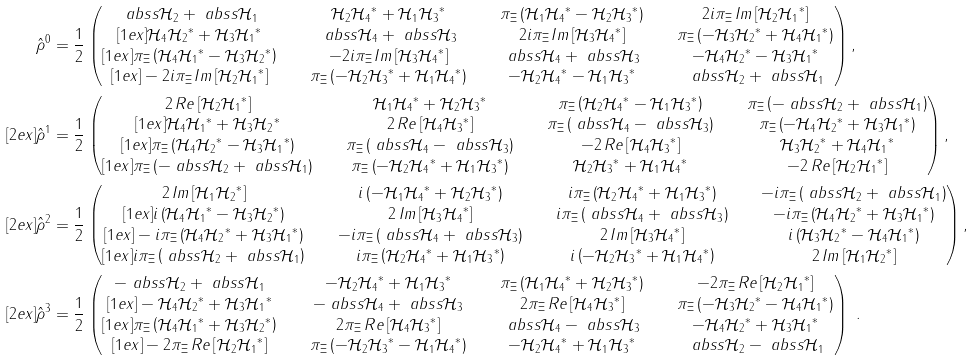<formula> <loc_0><loc_0><loc_500><loc_500>\hat { \rho } ^ { 0 } & = \frac { 1 } { 2 } \begin{pmatrix} \ a b s s { \mathcal { H } _ { 2 } } + \ a b s s { \mathcal { H } _ { 1 } } \quad & \mathcal { H } _ { 2 } { \mathcal { H } _ { 4 } } ^ { * } + \mathcal { H } _ { 1 } { \mathcal { H } _ { 3 } } ^ { * } \quad & \pi _ { \Xi } \left ( \mathcal { H } _ { 1 } { \mathcal { H } _ { 4 } } ^ { * } - \mathcal { H } _ { 2 } { \mathcal { H } _ { 3 } } ^ { * } \right ) \quad & 2 i \pi _ { \Xi } \, I m \left [ \mathcal { H } _ { 2 } { \mathcal { H } _ { 1 } } ^ { * } \right ] \\ [ 1 e x ] \mathcal { H } _ { 4 } { \mathcal { H } _ { 2 } } ^ { * } + \mathcal { H } _ { 3 } { \mathcal { H } _ { 1 } } ^ { * } \quad & \ a b s s { \mathcal { H } _ { 4 } } + \ a b s s { \mathcal { H } _ { 3 } } \quad & 2 i \pi _ { \Xi } \, I m \left [ \mathcal { H } _ { 3 } { \mathcal { H } _ { 4 } } ^ { * } \right ] \quad & \pi _ { \Xi } \left ( - \mathcal { H } _ { 3 } { \mathcal { H } _ { 2 } } ^ { * } + \mathcal { H } _ { 4 } { \mathcal { H } _ { 1 } } ^ { * } \right ) \\ [ 1 e x ] \pi _ { \Xi } \left ( \mathcal { H } _ { 4 } { \mathcal { H } _ { 1 } } ^ { * } - \mathcal { H } _ { 3 } { \mathcal { H } _ { 2 } } ^ { * } \right ) \quad & - 2 i \pi _ { \Xi } \, I m \left [ \mathcal { H } _ { 3 } { \mathcal { H } _ { 4 } } ^ { * } \right ] \quad & \ a b s s { \mathcal { H } _ { 4 } } + \ a b s s { \mathcal { H } _ { 3 } } \quad & - \mathcal { H } _ { 4 } { \mathcal { H } _ { 2 } } ^ { * } - \mathcal { H } _ { 3 } { \mathcal { H } _ { 1 } } ^ { * } \\ [ 1 e x ] - 2 i \pi _ { \Xi } \, I m \left [ \mathcal { H } _ { 2 } { \mathcal { H } _ { 1 } } ^ { * } \right ] \quad & \pi _ { \Xi } \left ( - \mathcal { H } _ { 2 } { \mathcal { H } _ { 3 } } ^ { * } + \mathcal { H } _ { 1 } { \mathcal { H } _ { 4 } } ^ { * } \right ) \quad & - \mathcal { H } _ { 2 } { \mathcal { H } _ { 4 } } ^ { * } - \mathcal { H } _ { 1 } { \mathcal { H } _ { 3 } } ^ { * } \quad & \ a b s s { \mathcal { H } _ { 2 } } + \ a b s s { \mathcal { H } _ { 1 } } \end{pmatrix} , \\ [ 2 e x ] \hat { \rho } ^ { 1 } & = \frac { 1 } { 2 } \begin{pmatrix} 2 \, R e \left [ \mathcal { H } _ { 2 } { \mathcal { H } _ { 1 } } ^ { * } \right ] \quad & \mathcal { H } _ { 1 } { \mathcal { H } _ { 4 } } ^ { * } + \mathcal { H } _ { 2 } { \mathcal { H } _ { 3 } } ^ { * } \quad & \pi _ { \Xi } \left ( \mathcal { H } _ { 2 } { \mathcal { H } _ { 4 } } ^ { * } - \mathcal { H } _ { 1 } { \mathcal { H } _ { 3 } } ^ { * } \right ) \quad & \pi _ { \Xi } \left ( - \ a b s s { \mathcal { H } _ { 2 } } + \ a b s s { \mathcal { H } _ { 1 } } \right ) \\ [ 1 e x ] \mathcal { H } _ { 4 } { \mathcal { H } _ { 1 } } ^ { * } + \mathcal { H } _ { 3 } { \mathcal { H } _ { 2 } } ^ { * } \quad & 2 \, R e \left [ \mathcal { H } _ { 4 } { \mathcal { H } _ { 3 } } ^ { * } \right ] \quad & \pi _ { \Xi } \left ( \ a b s s { \mathcal { H } _ { 4 } } - \ a b s s { \mathcal { H } _ { 3 } } \right ) \quad & \pi _ { \Xi } \left ( - \mathcal { H } _ { 4 } { \mathcal { H } _ { 2 } } ^ { * } + \mathcal { H } _ { 3 } { \mathcal { H } _ { 1 } } ^ { * } \right ) \\ [ 1 e x ] \pi _ { \Xi } \left ( \mathcal { H } _ { 4 } { \mathcal { H } _ { 2 } } ^ { * } - \mathcal { H } _ { 3 } { \mathcal { H } _ { 1 } } ^ { * } \right ) \quad & \pi _ { \Xi } \left ( \ a b s s { \mathcal { H } _ { 4 } } - \ a b s s { \mathcal { H } _ { 3 } } \right ) \quad & - 2 \, R e \left [ \mathcal { H } _ { 4 } { \mathcal { H } _ { 3 } } ^ { * } \right ] \quad & \mathcal { H } _ { 3 } { \mathcal { H } _ { 2 } } ^ { * } + \mathcal { H } _ { 4 } { \mathcal { H } _ { 1 } } ^ { * } \\ [ 1 e x ] \pi _ { \Xi } \left ( - \ a b s s { \mathcal { H } _ { 2 } } + \ a b s s { \mathcal { H } _ { 1 } } \right ) \quad & \pi _ { \Xi } \left ( - \mathcal { H } _ { 2 } { \mathcal { H } _ { 4 } } ^ { * } + \mathcal { H } _ { 1 } { \mathcal { H } _ { 3 } } ^ { * } \right ) \quad & \mathcal { H } _ { 2 } { \mathcal { H } _ { 3 } } ^ { * } + \mathcal { H } _ { 1 } { \mathcal { H } _ { 4 } } ^ { * } \quad & - 2 \, R e \left [ \mathcal { H } _ { 2 } { \mathcal { H } _ { 1 } } ^ { * } \right ] \end{pmatrix} , \\ [ 2 e x ] \hat { \rho } ^ { 2 } & = \frac { 1 } { 2 } \begin{pmatrix} 2 \, I m \left [ \mathcal { H } _ { 1 } { \mathcal { H } _ { 2 } } ^ { * } \right ] \quad & i \left ( - \mathcal { H } _ { 1 } { \mathcal { H } _ { 4 } } ^ { * } + \mathcal { H } _ { 2 } { \mathcal { H } _ { 3 } } ^ { * } \right ) \quad & i \pi _ { \Xi } \left ( \mathcal { H } _ { 2 } { \mathcal { H } _ { 4 } } ^ { * } + \mathcal { H } _ { 1 } { \mathcal { H } _ { 3 } } ^ { * } \right ) \quad & - i \pi _ { \Xi } \left ( \ a b s s { \mathcal { H } _ { 2 } } + \ a b s s { \mathcal { H } _ { 1 } } \right ) \\ [ 1 e x ] i \left ( \mathcal { H } _ { 4 } { \mathcal { H } _ { 1 } } ^ { * } - \mathcal { H } _ { 3 } { \mathcal { H } _ { 2 } } ^ { * } \right ) \quad & 2 \, I m \left [ \mathcal { H } _ { 3 } { \mathcal { H } _ { 4 } } ^ { * } \right ] \quad & i \pi _ { \Xi } \left ( \ a b s s { \mathcal { H } _ { 4 } } + \ a b s s { \mathcal { H } _ { 3 } } \right ) \quad & - i \pi _ { \Xi } \left ( \mathcal { H } _ { 4 } { \mathcal { H } _ { 2 } } ^ { * } + \mathcal { H } _ { 3 } { \mathcal { H } _ { 1 } } ^ { * } \right ) \\ [ 1 e x ] - i \pi _ { \Xi } \left ( \mathcal { H } _ { 4 } { \mathcal { H } _ { 2 } } ^ { * } + \mathcal { H } _ { 3 } { \mathcal { H } _ { 1 } } ^ { * } \right ) \quad & - i \pi _ { \Xi } \left ( \ a b s s { \mathcal { H } _ { 4 } } + \ a b s s { \mathcal { H } _ { 3 } } \right ) \quad & 2 \, I m \left [ \mathcal { H } _ { 3 } { \mathcal { H } _ { 4 } } ^ { * } \right ] \quad & i \left ( \mathcal { H } _ { 3 } { \mathcal { H } _ { 2 } } ^ { * } - \mathcal { H } _ { 4 } { \mathcal { H } _ { 1 } } ^ { * } \right ) \\ [ 1 e x ] i \pi _ { \Xi } \left ( \ a b s s { \mathcal { H } _ { 2 } } + \ a b s s { \mathcal { H } _ { 1 } } \right ) \quad & i \pi _ { \Xi } \left ( \mathcal { H } _ { 2 } { \mathcal { H } _ { 4 } } ^ { * } + \mathcal { H } _ { 1 } { \mathcal { H } _ { 3 } } ^ { * } \right ) \quad & i \left ( - \mathcal { H } _ { 2 } { \mathcal { H } _ { 3 } } ^ { * } + \mathcal { H } _ { 1 } { \mathcal { H } _ { 4 } } ^ { * } \right ) \quad & 2 \, I m \left [ \mathcal { H } _ { 1 } { \mathcal { H } _ { 2 } } ^ { * } \right ] \end{pmatrix} , \\ [ 2 e x ] \hat { \rho } ^ { 3 } & = \frac { 1 } { 2 } \begin{pmatrix} - \ a b s s { \mathcal { H } _ { 2 } } + \ a b s s { \mathcal { H } _ { 1 } } \quad & - \mathcal { H } _ { 2 } { \mathcal { H } _ { 4 } } ^ { * } + \mathcal { H } _ { 1 } { \mathcal { H } _ { 3 } } ^ { * } \quad & \pi _ { \Xi } \left ( \mathcal { H } _ { 1 } { \mathcal { H } _ { 4 } } ^ { * } + \mathcal { H } _ { 2 } { \mathcal { H } _ { 3 } } ^ { * } \right ) \quad & - 2 \pi _ { \Xi } \, R e \left [ \mathcal { H } _ { 2 } { \mathcal { H } _ { 1 } } ^ { * } \right ] \\ [ 1 e x ] - \mathcal { H } _ { 4 } { \mathcal { H } _ { 2 } } ^ { * } + \mathcal { H } _ { 3 } { \mathcal { H } _ { 1 } } ^ { * } \quad & - \ a b s s { \mathcal { H } _ { 4 } } + \ a b s s { \mathcal { H } _ { 3 } } \quad & 2 \pi _ { \Xi } \, R e \left [ \mathcal { H } _ { 4 } { \mathcal { H } _ { 3 } } ^ { * } \right ] \quad & \pi _ { \Xi } \left ( - \mathcal { H } _ { 3 } { \mathcal { H } _ { 2 } } ^ { * } - \mathcal { H } _ { 4 } { \mathcal { H } _ { 1 } } ^ { * } \right ) \\ [ 1 e x ] \pi _ { \Xi } \left ( \mathcal { H } _ { 4 } { \mathcal { H } _ { 1 } } ^ { * } + \mathcal { H } _ { 3 } { \mathcal { H } _ { 2 } } ^ { * } \right ) \quad & 2 \pi _ { \Xi } \, R e \left [ \mathcal { H } _ { 4 } { \mathcal { H } _ { 3 } } ^ { * } \right ] \quad & \ a b s s { \mathcal { H } _ { 4 } } - \ a b s s { \mathcal { H } _ { 3 } } \quad & - \mathcal { H } _ { 4 } { \mathcal { H } _ { 2 } } ^ { * } + \mathcal { H } _ { 3 } { \mathcal { H } _ { 1 } } ^ { * } \\ [ 1 e x ] - 2 \pi _ { \Xi } \, R e \left [ \mathcal { H } _ { 2 } { \mathcal { H } _ { 1 } } ^ { * } \right ] \quad & \pi _ { \Xi } \left ( - \mathcal { H } _ { 2 } { \mathcal { H } _ { 3 } } ^ { * } - \mathcal { H } _ { 1 } { \mathcal { H } _ { 4 } } ^ { * } \right ) \quad & - \mathcal { H } _ { 2 } { \mathcal { H } _ { 4 } } ^ { * } + \mathcal { H } _ { 1 } { \mathcal { H } _ { 3 } } ^ { * } \quad & \ a b s s { \mathcal { H } _ { 2 } } - \ a b s s { \mathcal { H } _ { 1 } } \end{pmatrix} \ .</formula> 